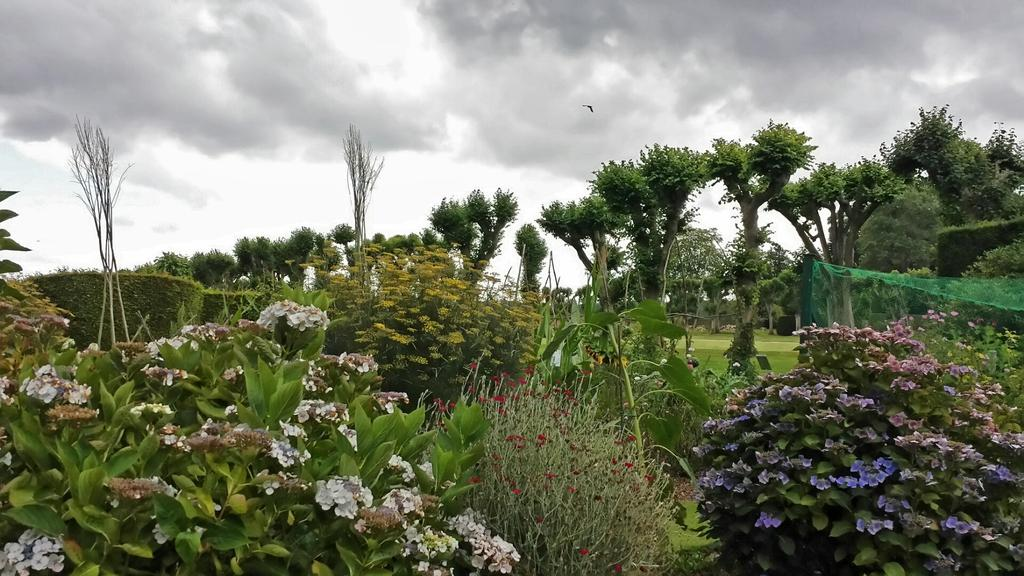What type of vegetation can be seen in the image? There are many plants and trees in the image. What is the color of the grass on the ground? The grass on the ground is green. What can be seen in the sky in the image? There are clouds in the sky. In which direction are the plants facing in the image? The direction in which the plants are facing cannot be determined from the image, as they are stationary and not facing a specific direction. 